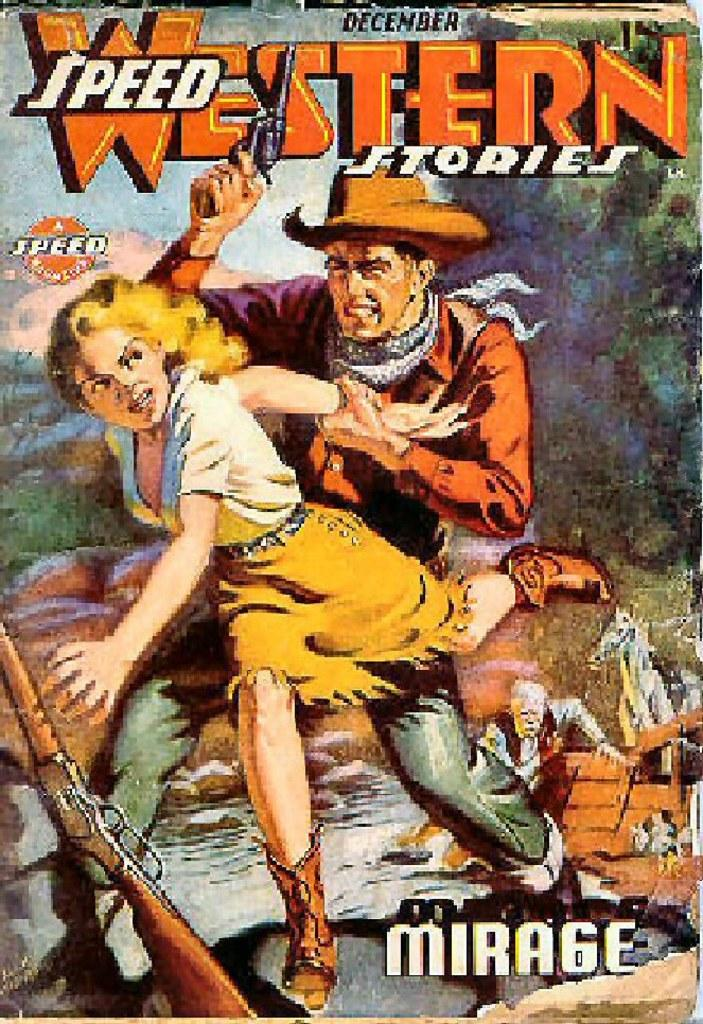<image>
Share a concise interpretation of the image provided. A December issue of Speed Western Stories with a man and woman on the cover. 